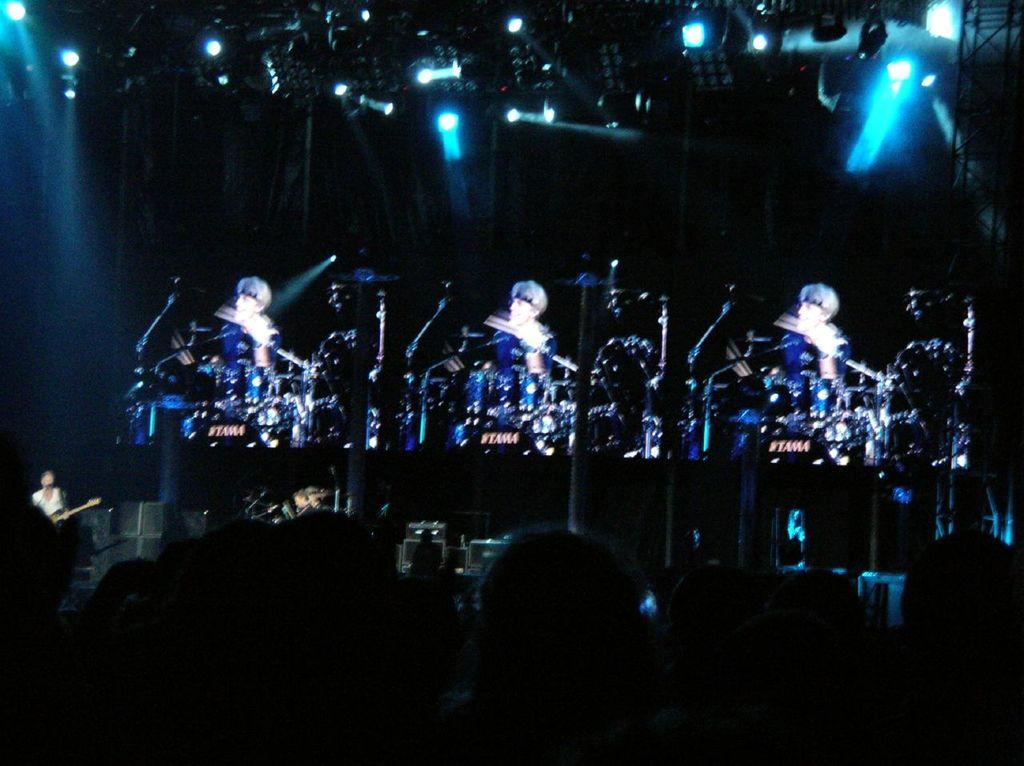How many musicians are playing in the image? There are three musicians playing in the image. What can be seen above the musicians? There are lights above the musicians. Who is present in front of the musicians? There is an audience in front of the musicians. Can you tell me how many battles are taking place in the background of the image? There are no battles present in the image; it features musicians playing instruments with an audience in front of them. What type of sofa can be seen in the image? There is no sofa present in the image. 